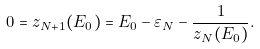Convert formula to latex. <formula><loc_0><loc_0><loc_500><loc_500>0 = z _ { N + 1 } ( E _ { 0 } ) = E _ { 0 } - \varepsilon _ { N } - \frac { 1 } { z _ { N } ( E _ { 0 } ) } .</formula> 